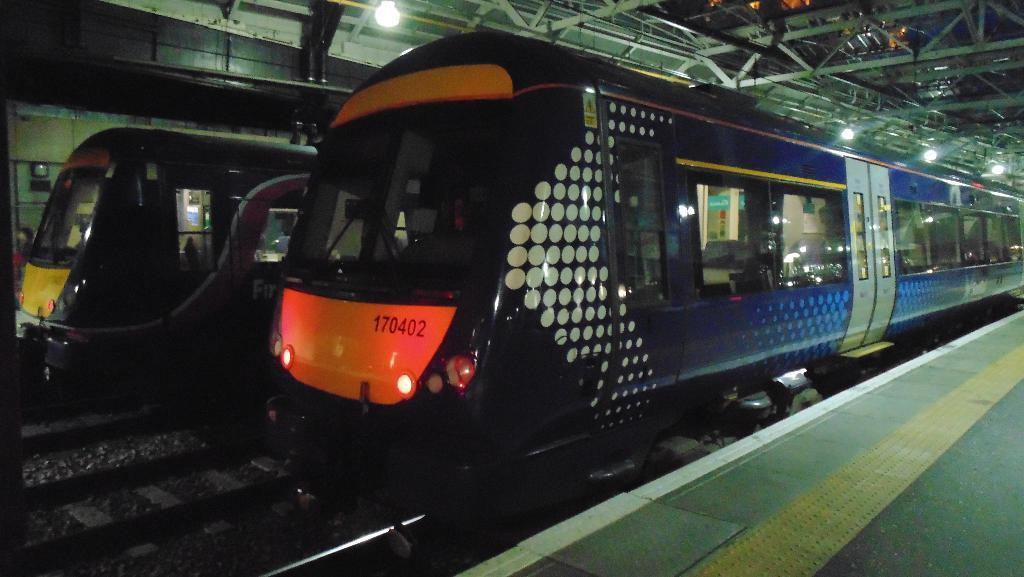What can be seen on the railway tracks in the image? There are trains on the railway tracks in the image. What is located beside the trains? There are platforms beside the trains. What features can be observed on the platforms? Lights, rods, and a roof are visible on the platforms. Are there any other objects present on the platforms? Yes, there are other objects on the platforms. How many ants can be seen carrying an account on the platform in the image? There are no ants or accounts present in the image; the focus is on the trains, platforms, and their features. 